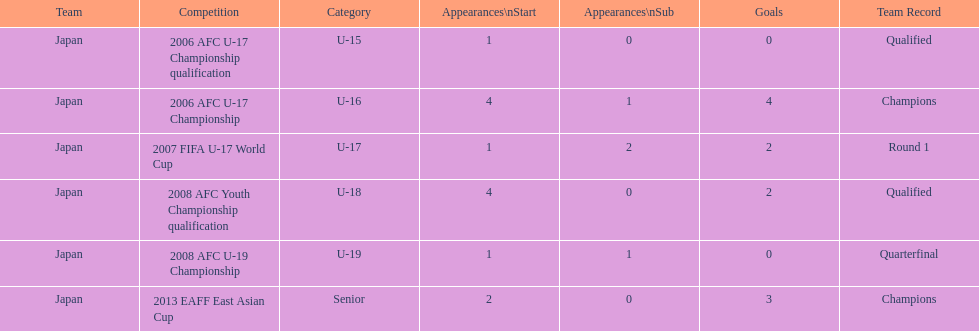Yoichiro kakitani scored above 2 goals in how many major competitions? 2. 